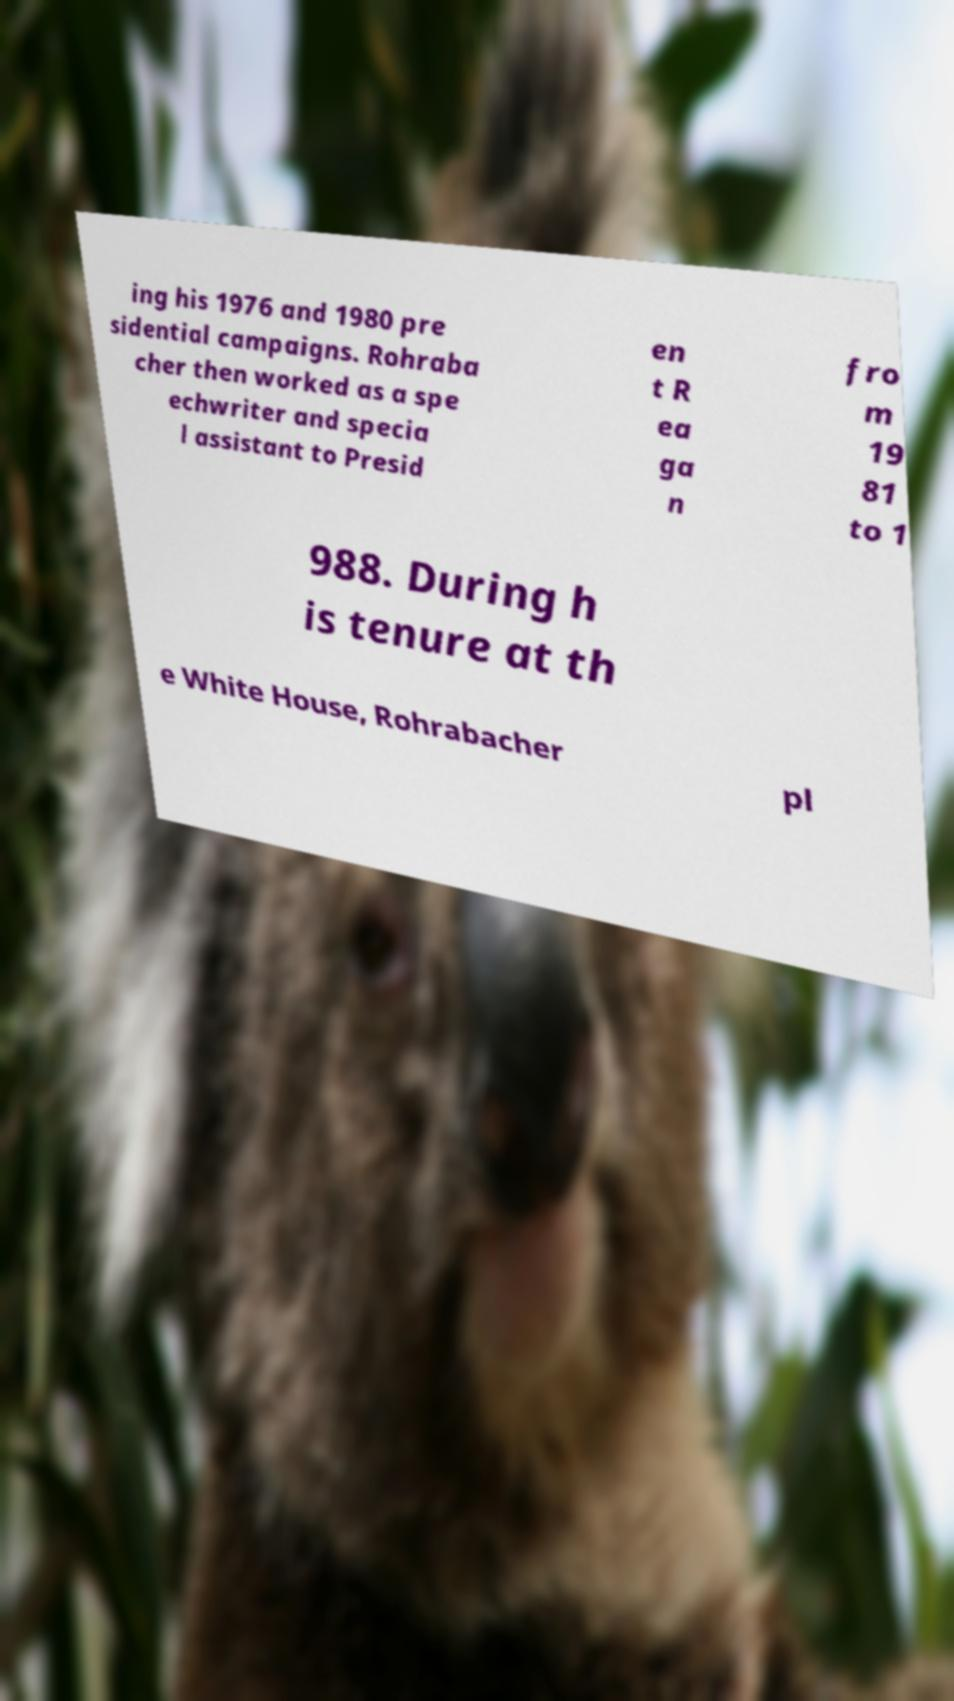Could you extract and type out the text from this image? ing his 1976 and 1980 pre sidential campaigns. Rohraba cher then worked as a spe echwriter and specia l assistant to Presid en t R ea ga n fro m 19 81 to 1 988. During h is tenure at th e White House, Rohrabacher pl 